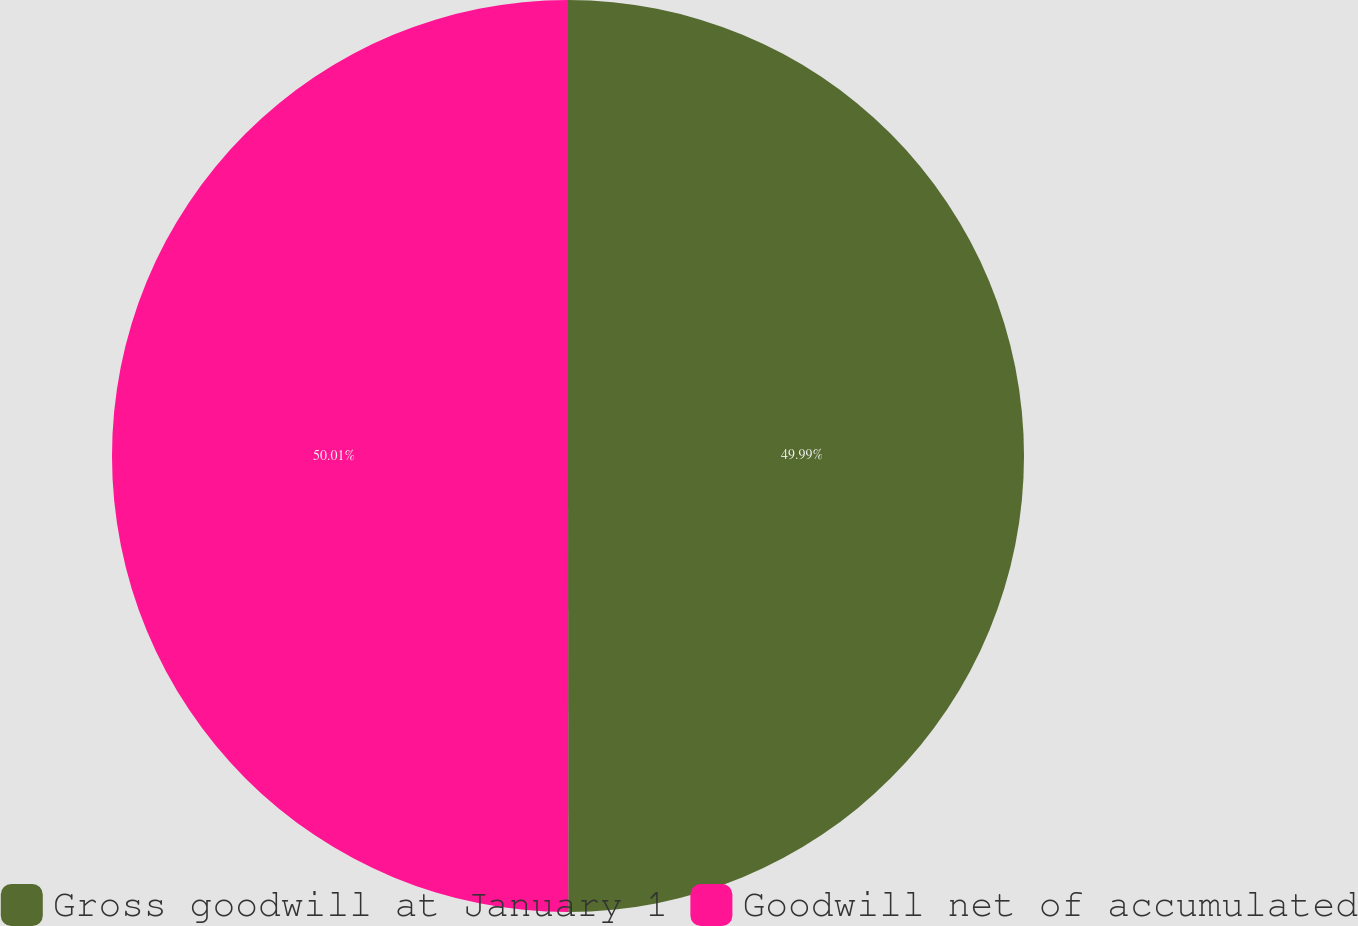Convert chart. <chart><loc_0><loc_0><loc_500><loc_500><pie_chart><fcel>Gross goodwill at January 1<fcel>Goodwill net of accumulated<nl><fcel>49.99%<fcel>50.01%<nl></chart> 